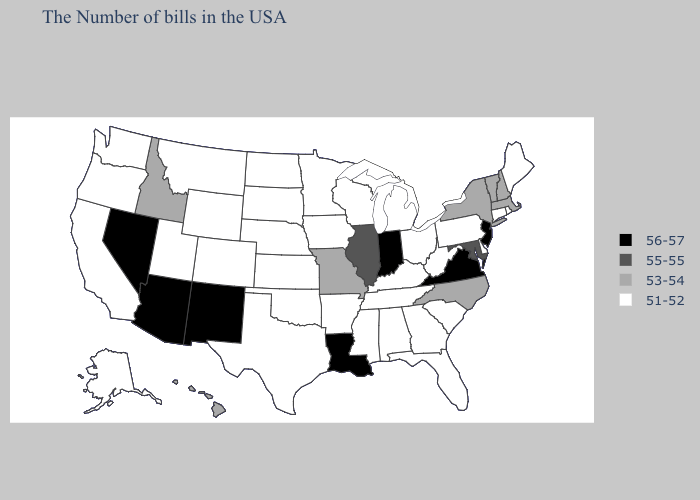What is the value of Arkansas?
Keep it brief. 51-52. Name the states that have a value in the range 55-55?
Write a very short answer. Maryland, Illinois. What is the highest value in the MidWest ?
Short answer required. 56-57. Does Maryland have the lowest value in the USA?
Answer briefly. No. Among the states that border Louisiana , which have the lowest value?
Concise answer only. Mississippi, Arkansas, Texas. Name the states that have a value in the range 53-54?
Concise answer only. Massachusetts, New Hampshire, Vermont, New York, North Carolina, Missouri, Idaho, Hawaii. Which states have the lowest value in the West?
Keep it brief. Wyoming, Colorado, Utah, Montana, California, Washington, Oregon, Alaska. What is the value of North Carolina?
Short answer required. 53-54. What is the value of Louisiana?
Be succinct. 56-57. Does Minnesota have the lowest value in the MidWest?
Give a very brief answer. Yes. What is the highest value in states that border Kentucky?
Concise answer only. 56-57. Among the states that border Pennsylvania , which have the lowest value?
Short answer required. Delaware, West Virginia, Ohio. Which states have the highest value in the USA?
Write a very short answer. New Jersey, Virginia, Indiana, Louisiana, New Mexico, Arizona, Nevada. Does Maryland have the lowest value in the South?
Short answer required. No. What is the highest value in the USA?
Answer briefly. 56-57. 